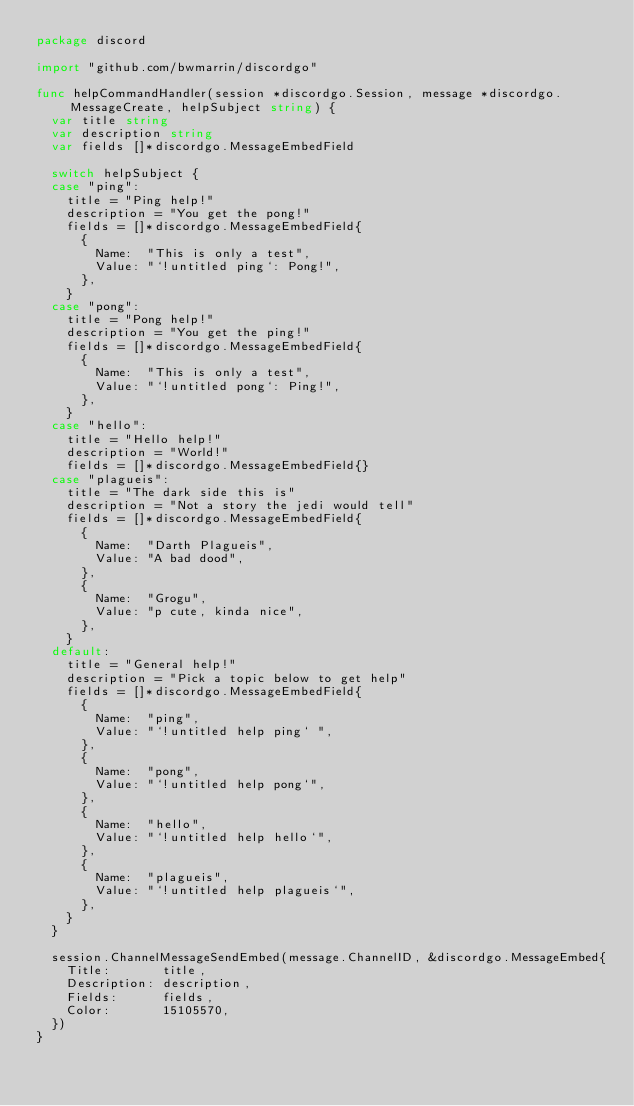Convert code to text. <code><loc_0><loc_0><loc_500><loc_500><_Go_>package discord

import "github.com/bwmarrin/discordgo"

func helpCommandHandler(session *discordgo.Session, message *discordgo.MessageCreate, helpSubject string) {
	var title string
	var description string
	var fields []*discordgo.MessageEmbedField

	switch helpSubject {
	case "ping":
		title = "Ping help!"
		description = "You get the pong!"
		fields = []*discordgo.MessageEmbedField{
			{
				Name:  "This is only a test",
				Value: "`!untitled ping`: Pong!",
			},
		}
	case "pong":
		title = "Pong help!"
		description = "You get the ping!"
		fields = []*discordgo.MessageEmbedField{
			{
				Name:  "This is only a test",
				Value: "`!untitled pong`: Ping!",
			},
		}
	case "hello":
		title = "Hello help!"
		description = "World!"
		fields = []*discordgo.MessageEmbedField{}
	case "plagueis":
		title = "The dark side this is"
		description = "Not a story the jedi would tell"
		fields = []*discordgo.MessageEmbedField{
			{
				Name:  "Darth Plagueis",
				Value: "A bad dood",
			},
			{
				Name:  "Grogu",
				Value: "p cute, kinda nice",
			},
		}
	default:
		title = "General help!"
		description = "Pick a topic below to get help"
		fields = []*discordgo.MessageEmbedField{
			{
				Name:  "ping",
				Value: "`!untitled help ping` ",
			},
			{
				Name:  "pong",
				Value: "`!untitled help pong`",
			},
			{
				Name:  "hello",
				Value: "`!untitled help hello`",
			},
			{
				Name:  "plagueis",
				Value: "`!untitled help plagueis`",
			},
		}
	}

	session.ChannelMessageSendEmbed(message.ChannelID, &discordgo.MessageEmbed{
		Title:       title,
		Description: description,
		Fields:      fields,
		Color:       15105570,
	})
}
</code> 